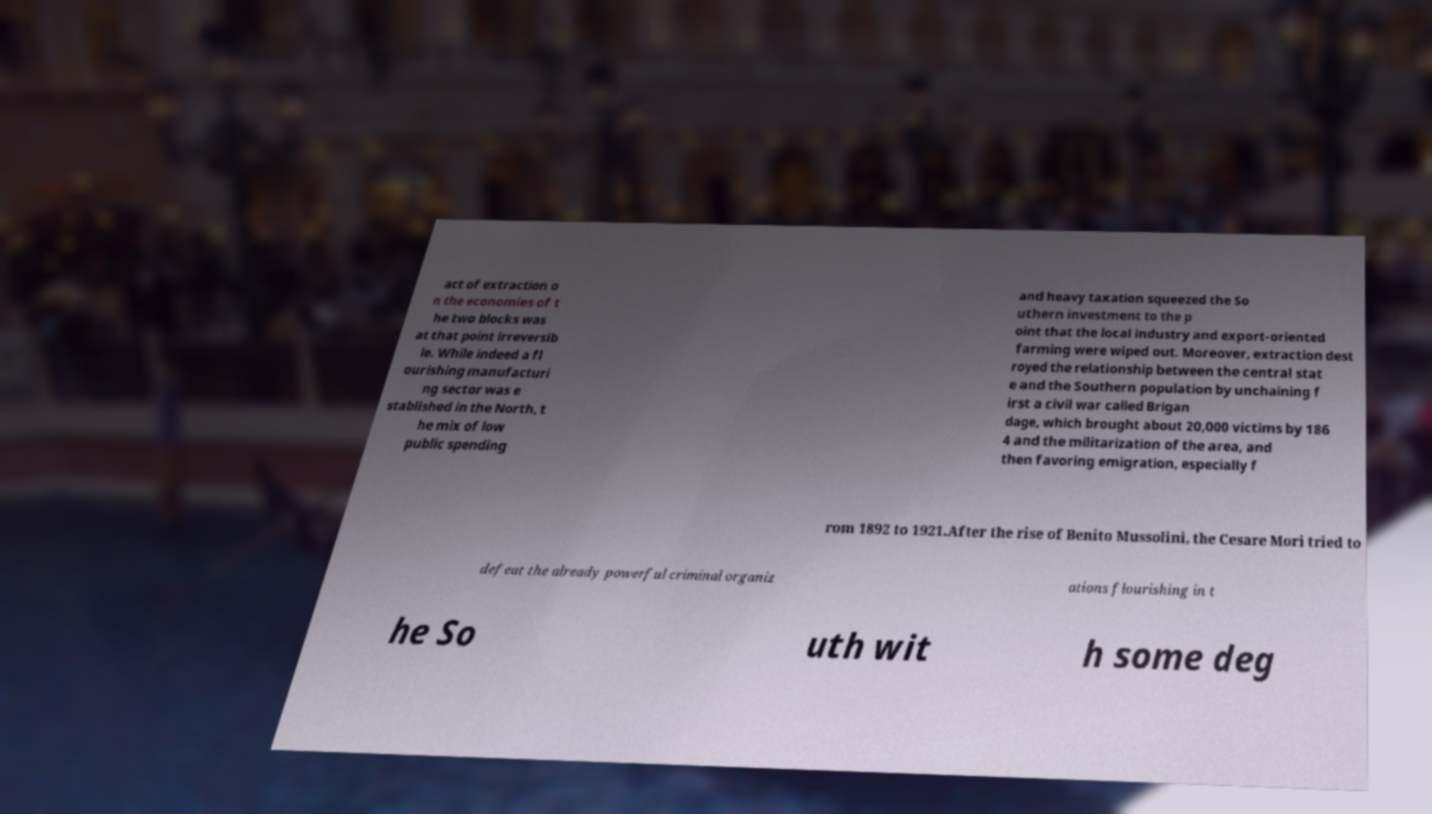Please identify and transcribe the text found in this image. act of extraction o n the economies of t he two blocks was at that point irreversib le. While indeed a fl ourishing manufacturi ng sector was e stablished in the North, t he mix of low public spending and heavy taxation squeezed the So uthern investment to the p oint that the local industry and export-oriented farming were wiped out. Moreover, extraction dest royed the relationship between the central stat e and the Southern population by unchaining f irst a civil war called Brigan dage, which brought about 20,000 victims by 186 4 and the militarization of the area, and then favoring emigration, especially f rom 1892 to 1921.After the rise of Benito Mussolini, the Cesare Mori tried to defeat the already powerful criminal organiz ations flourishing in t he So uth wit h some deg 